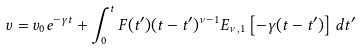Convert formula to latex. <formula><loc_0><loc_0><loc_500><loc_500>v = v _ { 0 } e ^ { - \gamma t } + \int ^ { t } _ { 0 } F ( t ^ { \prime } ) ( t - t ^ { \prime } ) ^ { \nu - 1 } E _ { \nu , 1 } \left [ - \gamma ( t - t ^ { \prime } ) \right ] d t ^ { \prime }</formula> 